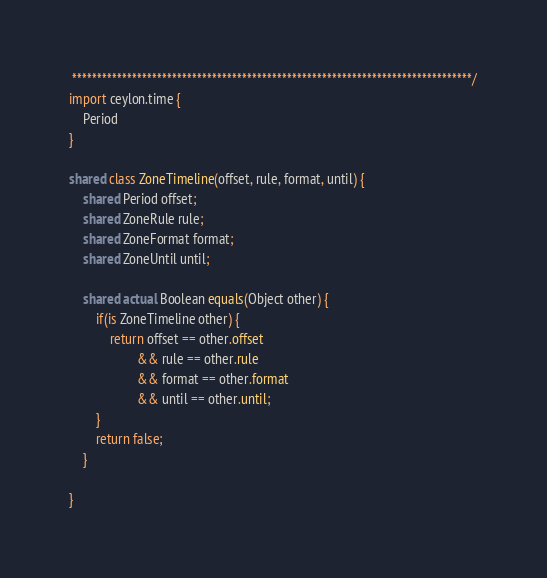Convert code to text. <code><loc_0><loc_0><loc_500><loc_500><_Ceylon_> ********************************************************************************/
import ceylon.time {
    Period
}

shared class ZoneTimeline(offset, rule, format, until) {
    shared Period offset;
    shared ZoneRule rule;
    shared ZoneFormat format;
    shared ZoneUntil until;
    
    shared actual Boolean equals(Object other) {
        if(is ZoneTimeline other) {
            return offset == other.offset
                    && rule == other.rule
                    && format == other.format
                    && until == other.until;
        }
        return false;
    }
    
}</code> 